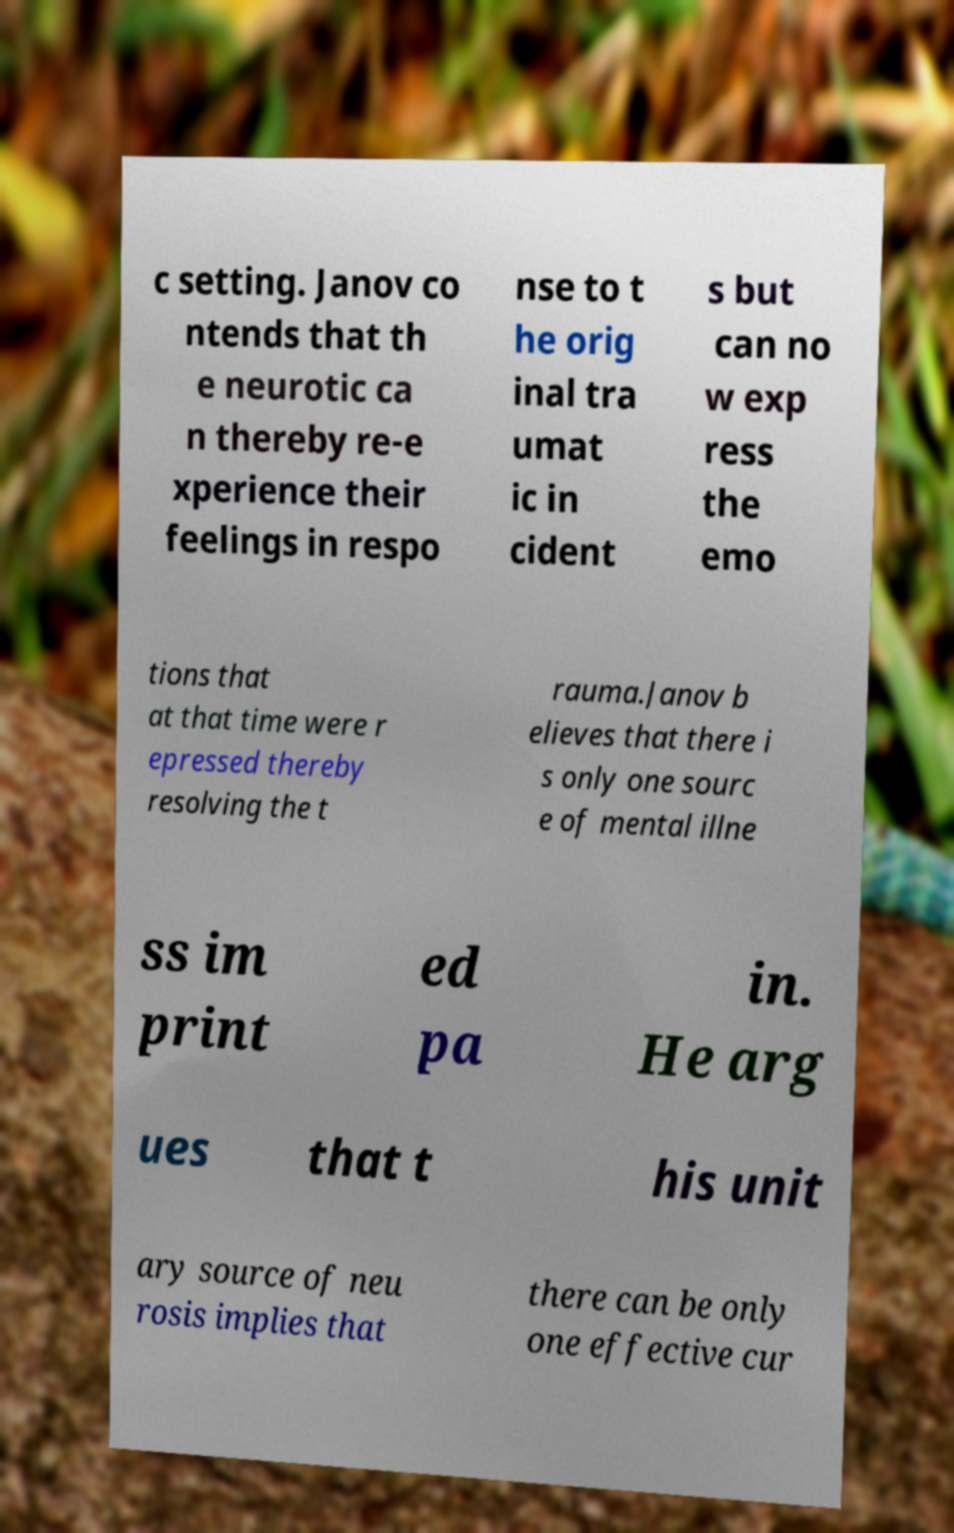Please read and relay the text visible in this image. What does it say? c setting. Janov co ntends that th e neurotic ca n thereby re-e xperience their feelings in respo nse to t he orig inal tra umat ic in cident s but can no w exp ress the emo tions that at that time were r epressed thereby resolving the t rauma.Janov b elieves that there i s only one sourc e of mental illne ss im print ed pa in. He arg ues that t his unit ary source of neu rosis implies that there can be only one effective cur 